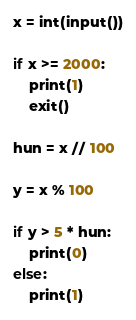<code> <loc_0><loc_0><loc_500><loc_500><_Python_>x = int(input())

if x >= 2000:
    print(1)
    exit()

hun = x // 100

y = x % 100

if y > 5 * hun:
    print(0)
else:
    print(1)</code> 